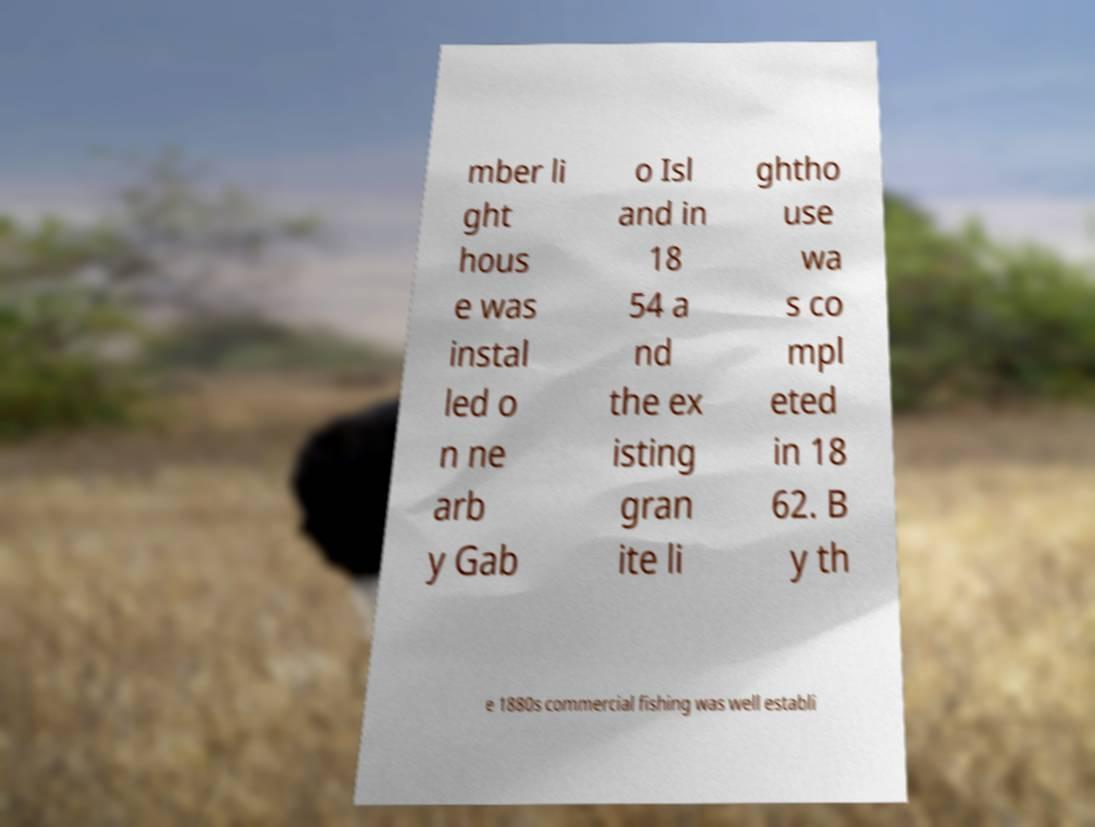Could you extract and type out the text from this image? mber li ght hous e was instal led o n ne arb y Gab o Isl and in 18 54 a nd the ex isting gran ite li ghtho use wa s co mpl eted in 18 62. B y th e 1880s commercial fishing was well establi 